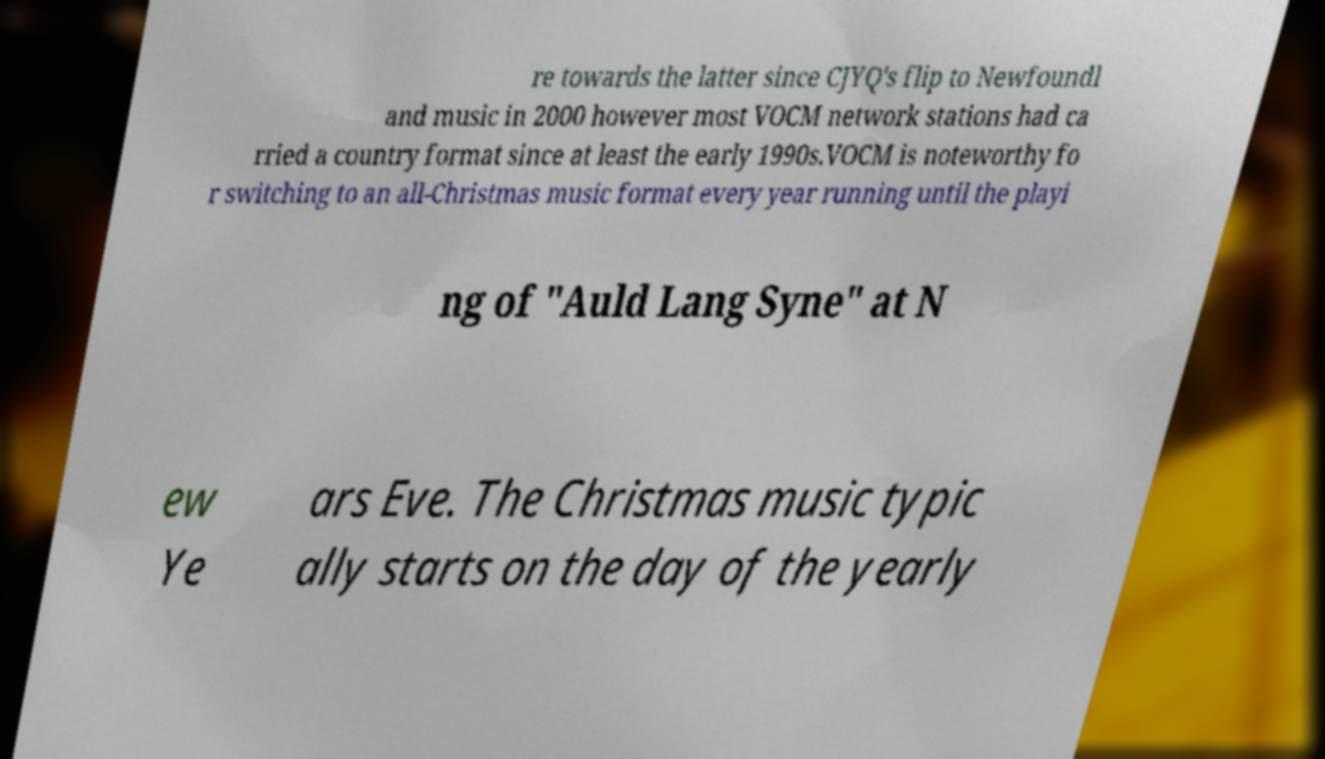Could you assist in decoding the text presented in this image and type it out clearly? re towards the latter since CJYQ's flip to Newfoundl and music in 2000 however most VOCM network stations had ca rried a country format since at least the early 1990s.VOCM is noteworthy fo r switching to an all-Christmas music format every year running until the playi ng of "Auld Lang Syne" at N ew Ye ars Eve. The Christmas music typic ally starts on the day of the yearly 